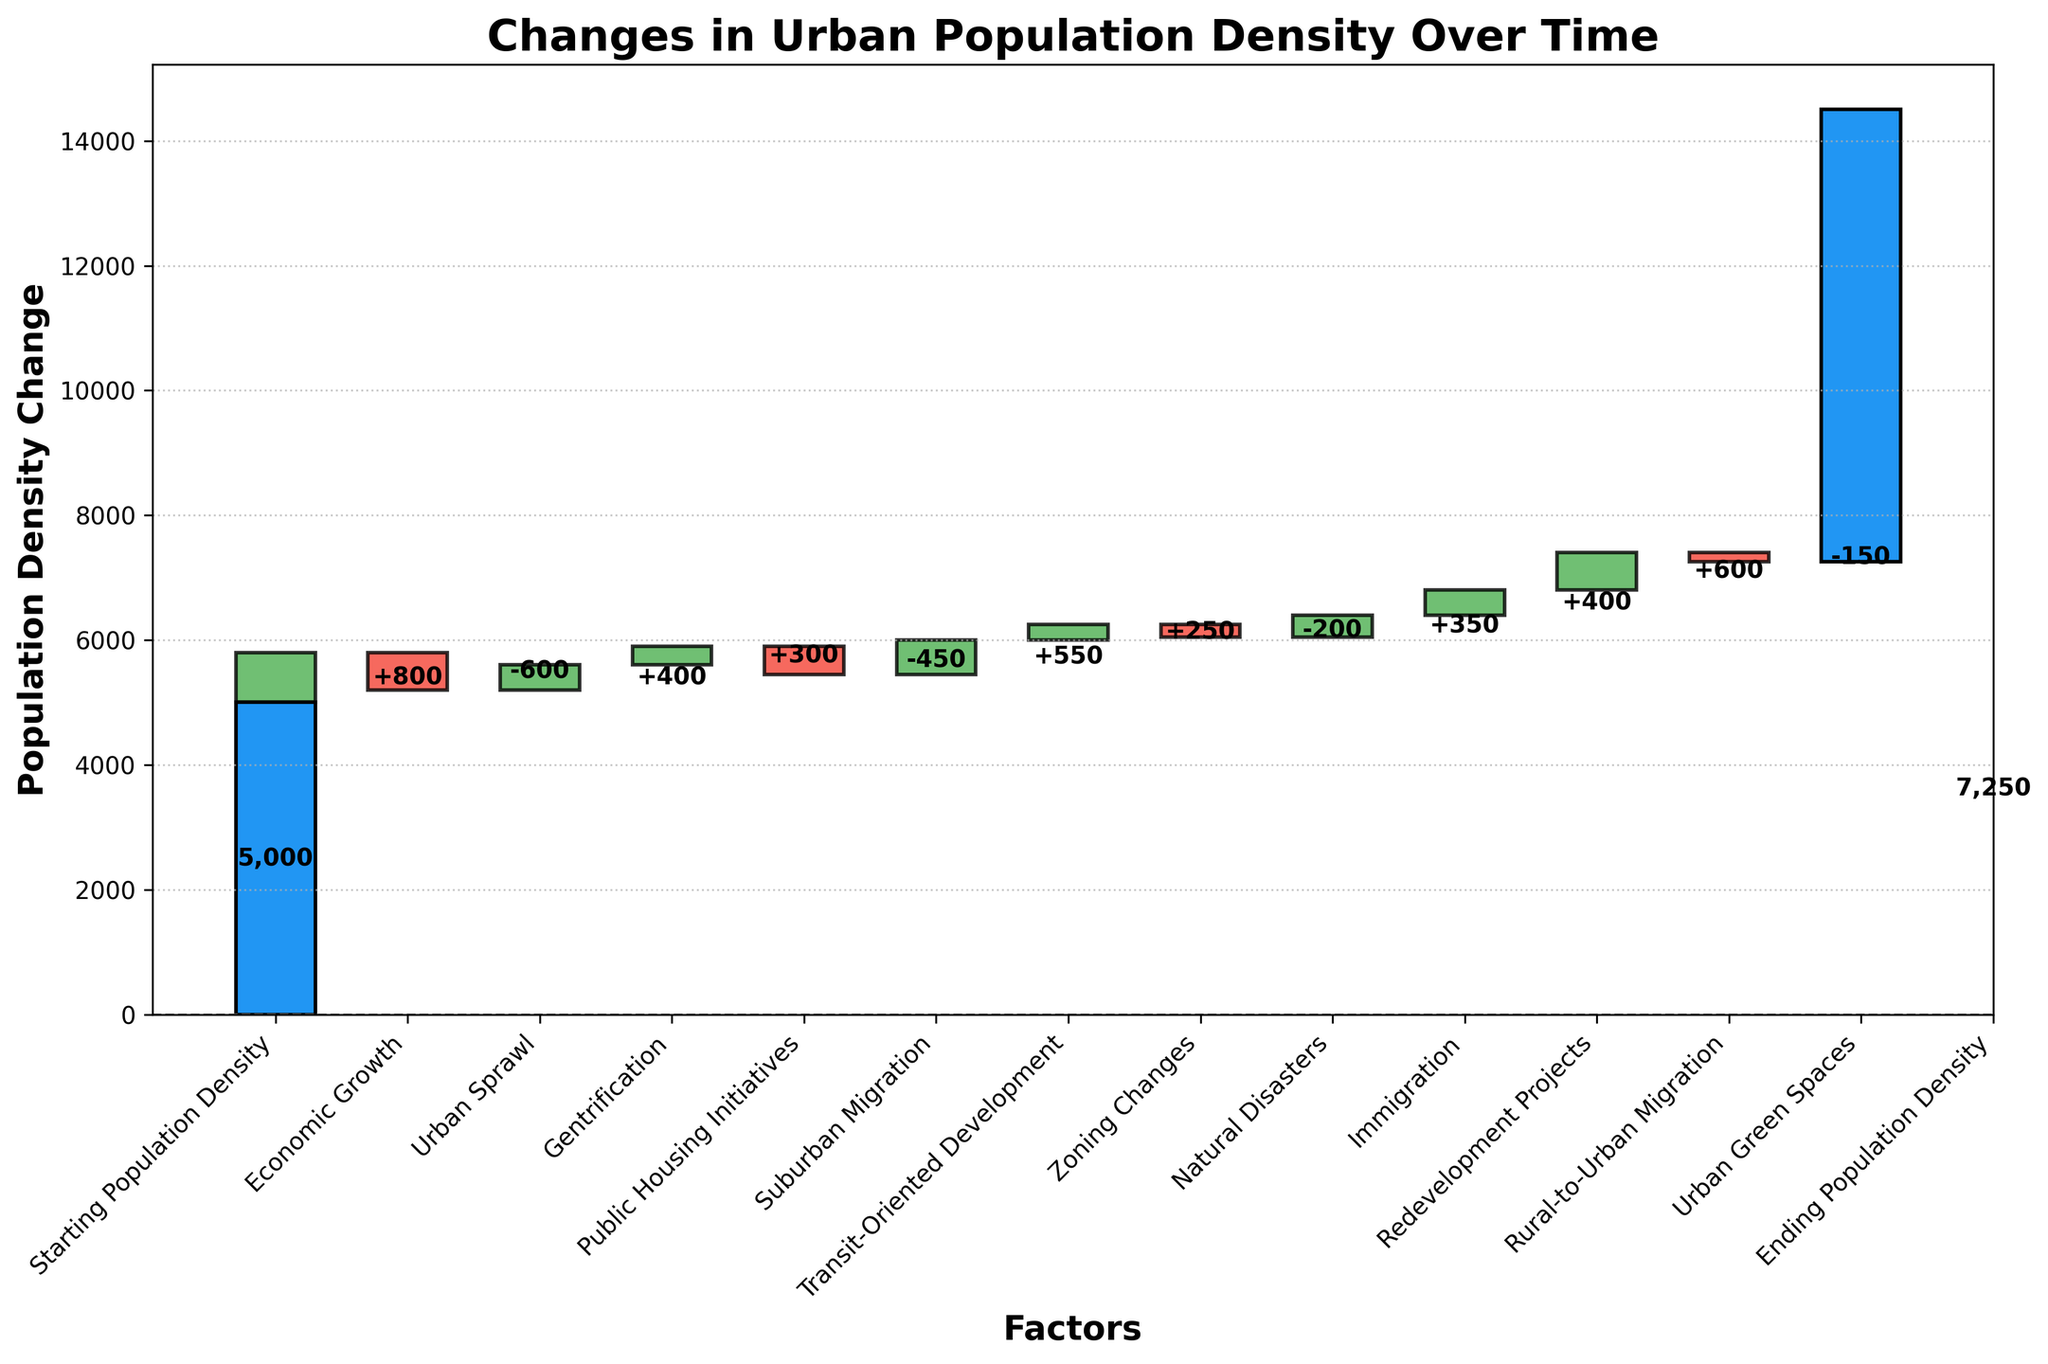What is the title of the chart? The title of the chart is displayed at the top of the figure. It reads "Changes in Urban Population Density Over Time".
Answer: Changes in Urban Population Density Over Time Which factor contributed the most to the decrease in population density? To find the largest decrease, look at the red bars (negative values). Urban Sprawl has the largest negative value of -600.
Answer: Urban Sprawl What is the total increase in population density due to Economic Growth and Gentrification? Add the values for Economic Growth (800) and Gentrification (400) to get the total increase. 800 + 400 = 1200.
Answer: 1200 How much did public housing initiatives contribute to the change in population density? Find the value next to Public Housing Initiatives. It is a green bar with a value of 300.
Answer: 300 Which factor had a positive impact but lower than Transit-Oriented Development? Identify the positive factors (green bars) and compare them to the value of Transit-Oriented Development (550). The next highest positive factor less than 550 is Immigration with a value of 350.
Answer: Immigration What is the final population density? The final population density is given by the Ending Population Density bar. It is labeled as 7250.
Answer: 7250 Is the impact of Rural-to-Urban Migration greater than the impact of Immigration? Compare the heights of the Rural-to-Urban Migration bar (600) and Immigration bar (350). 600 is greater than 350.
Answer: Yes What is the combined effect of Urban Sprawl and Suburban Migration on population density? Add the values for Urban Sprawl (-600) and Suburban Migration (-450). -600 + (-450) = -1050.
Answer: -1050 How many factors contributed to the increase in population density? Count the number of green bars (positive values). There are 8 factors that contribute to an increase.
Answer: 8 What is the cumulative impact of the negative factors on population density? Add the values of all the red bars: Urban Sprawl (-600), Suburban Migration (-450), Natural Disasters (-200), Urban Green Spaces (-150). -600 + (-450) + (-200) + (-150) = -1400.
Answer: -1400 